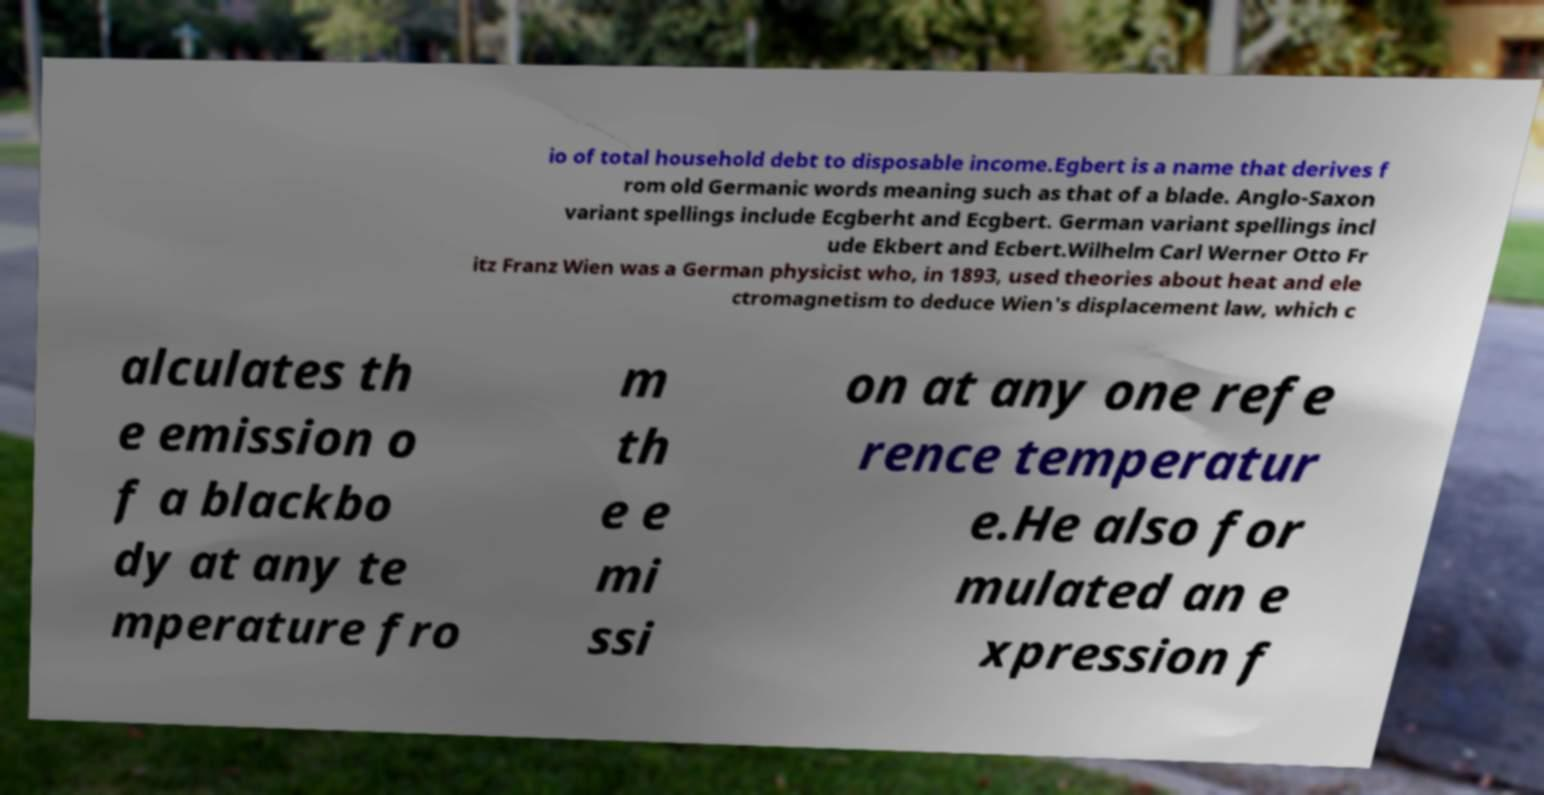Could you assist in decoding the text presented in this image and type it out clearly? io of total household debt to disposable income.Egbert is a name that derives f rom old Germanic words meaning such as that of a blade. Anglo-Saxon variant spellings include Ecgberht and Ecgbert. German variant spellings incl ude Ekbert and Ecbert.Wilhelm Carl Werner Otto Fr itz Franz Wien was a German physicist who, in 1893, used theories about heat and ele ctromagnetism to deduce Wien's displacement law, which c alculates th e emission o f a blackbo dy at any te mperature fro m th e e mi ssi on at any one refe rence temperatur e.He also for mulated an e xpression f 